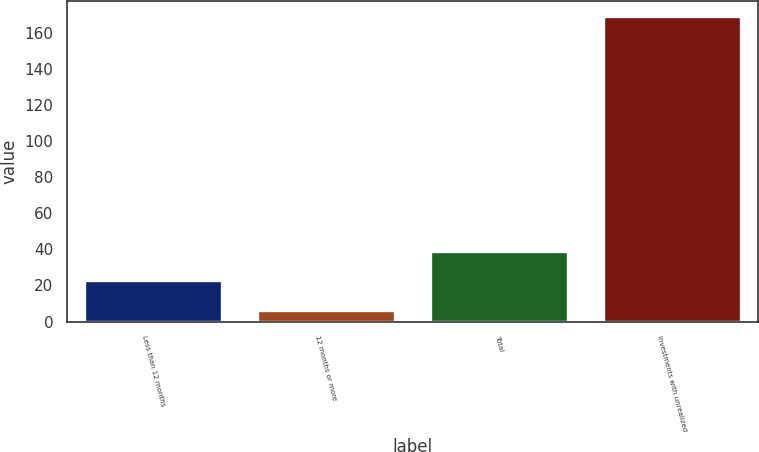Convert chart. <chart><loc_0><loc_0><loc_500><loc_500><bar_chart><fcel>Less than 12 months<fcel>12 months or more<fcel>Total<fcel>Investments with unrealized<nl><fcel>22.8<fcel>6.3<fcel>39.1<fcel>169.3<nl></chart> 